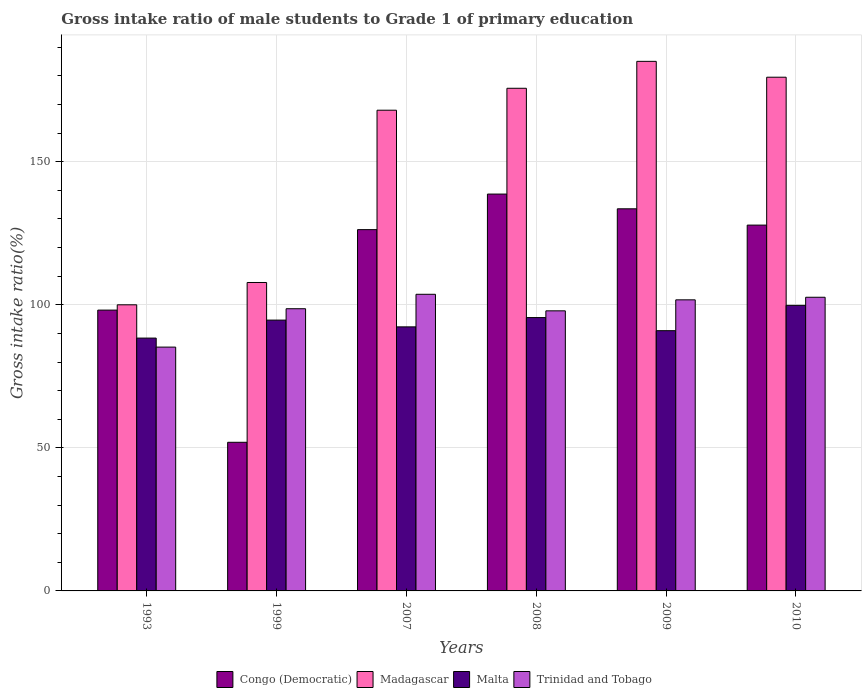How many different coloured bars are there?
Give a very brief answer. 4. How many groups of bars are there?
Offer a terse response. 6. Are the number of bars per tick equal to the number of legend labels?
Make the answer very short. Yes. Are the number of bars on each tick of the X-axis equal?
Offer a very short reply. Yes. How many bars are there on the 2nd tick from the left?
Your answer should be compact. 4. How many bars are there on the 2nd tick from the right?
Your answer should be very brief. 4. What is the label of the 5th group of bars from the left?
Your response must be concise. 2009. In how many cases, is the number of bars for a given year not equal to the number of legend labels?
Keep it short and to the point. 0. What is the gross intake ratio in Madagascar in 1993?
Ensure brevity in your answer.  99.99. Across all years, what is the maximum gross intake ratio in Madagascar?
Your response must be concise. 185.07. Across all years, what is the minimum gross intake ratio in Trinidad and Tobago?
Give a very brief answer. 85.21. In which year was the gross intake ratio in Congo (Democratic) maximum?
Your answer should be very brief. 2008. What is the total gross intake ratio in Malta in the graph?
Your answer should be very brief. 561.55. What is the difference between the gross intake ratio in Congo (Democratic) in 1999 and that in 2010?
Your response must be concise. -75.9. What is the difference between the gross intake ratio in Malta in 2008 and the gross intake ratio in Madagascar in 2009?
Your answer should be very brief. -89.54. What is the average gross intake ratio in Trinidad and Tobago per year?
Keep it short and to the point. 98.29. In the year 1993, what is the difference between the gross intake ratio in Malta and gross intake ratio in Madagascar?
Your answer should be very brief. -11.63. What is the ratio of the gross intake ratio in Trinidad and Tobago in 1999 to that in 2009?
Make the answer very short. 0.97. Is the difference between the gross intake ratio in Malta in 1999 and 2007 greater than the difference between the gross intake ratio in Madagascar in 1999 and 2007?
Offer a very short reply. Yes. What is the difference between the highest and the second highest gross intake ratio in Congo (Democratic)?
Ensure brevity in your answer.  5.15. What is the difference between the highest and the lowest gross intake ratio in Malta?
Your response must be concise. 11.44. In how many years, is the gross intake ratio in Malta greater than the average gross intake ratio in Malta taken over all years?
Offer a terse response. 3. Is the sum of the gross intake ratio in Congo (Democratic) in 1993 and 1999 greater than the maximum gross intake ratio in Trinidad and Tobago across all years?
Provide a succinct answer. Yes. What does the 4th bar from the left in 2010 represents?
Provide a short and direct response. Trinidad and Tobago. What does the 3rd bar from the right in 2008 represents?
Make the answer very short. Madagascar. How many bars are there?
Offer a very short reply. 24. Are all the bars in the graph horizontal?
Your answer should be very brief. No. How many years are there in the graph?
Your response must be concise. 6. What is the difference between two consecutive major ticks on the Y-axis?
Give a very brief answer. 50. Are the values on the major ticks of Y-axis written in scientific E-notation?
Keep it short and to the point. No. Does the graph contain grids?
Make the answer very short. Yes. How many legend labels are there?
Ensure brevity in your answer.  4. How are the legend labels stacked?
Ensure brevity in your answer.  Horizontal. What is the title of the graph?
Provide a short and direct response. Gross intake ratio of male students to Grade 1 of primary education. What is the label or title of the X-axis?
Provide a succinct answer. Years. What is the label or title of the Y-axis?
Ensure brevity in your answer.  Gross intake ratio(%). What is the Gross intake ratio(%) of Congo (Democratic) in 1993?
Give a very brief answer. 98.14. What is the Gross intake ratio(%) of Madagascar in 1993?
Offer a very short reply. 99.99. What is the Gross intake ratio(%) of Malta in 1993?
Your response must be concise. 88.36. What is the Gross intake ratio(%) of Trinidad and Tobago in 1993?
Your response must be concise. 85.21. What is the Gross intake ratio(%) in Congo (Democratic) in 1999?
Offer a very short reply. 51.94. What is the Gross intake ratio(%) of Madagascar in 1999?
Offer a very short reply. 107.79. What is the Gross intake ratio(%) in Malta in 1999?
Make the answer very short. 94.64. What is the Gross intake ratio(%) in Trinidad and Tobago in 1999?
Keep it short and to the point. 98.62. What is the Gross intake ratio(%) in Congo (Democratic) in 2007?
Offer a terse response. 126.26. What is the Gross intake ratio(%) in Madagascar in 2007?
Give a very brief answer. 168. What is the Gross intake ratio(%) in Malta in 2007?
Ensure brevity in your answer.  92.28. What is the Gross intake ratio(%) of Trinidad and Tobago in 2007?
Provide a short and direct response. 103.66. What is the Gross intake ratio(%) of Congo (Democratic) in 2008?
Provide a short and direct response. 138.69. What is the Gross intake ratio(%) in Madagascar in 2008?
Give a very brief answer. 175.66. What is the Gross intake ratio(%) of Malta in 2008?
Offer a very short reply. 95.53. What is the Gross intake ratio(%) of Trinidad and Tobago in 2008?
Your answer should be compact. 97.88. What is the Gross intake ratio(%) of Congo (Democratic) in 2009?
Offer a very short reply. 133.54. What is the Gross intake ratio(%) of Madagascar in 2009?
Offer a terse response. 185.07. What is the Gross intake ratio(%) in Malta in 2009?
Offer a very short reply. 90.94. What is the Gross intake ratio(%) in Trinidad and Tobago in 2009?
Provide a succinct answer. 101.72. What is the Gross intake ratio(%) of Congo (Democratic) in 2010?
Your response must be concise. 127.85. What is the Gross intake ratio(%) of Madagascar in 2010?
Keep it short and to the point. 179.53. What is the Gross intake ratio(%) of Malta in 2010?
Your answer should be very brief. 99.8. What is the Gross intake ratio(%) of Trinidad and Tobago in 2010?
Give a very brief answer. 102.63. Across all years, what is the maximum Gross intake ratio(%) of Congo (Democratic)?
Provide a short and direct response. 138.69. Across all years, what is the maximum Gross intake ratio(%) in Madagascar?
Provide a succinct answer. 185.07. Across all years, what is the maximum Gross intake ratio(%) of Malta?
Give a very brief answer. 99.8. Across all years, what is the maximum Gross intake ratio(%) of Trinidad and Tobago?
Offer a terse response. 103.66. Across all years, what is the minimum Gross intake ratio(%) in Congo (Democratic)?
Your response must be concise. 51.94. Across all years, what is the minimum Gross intake ratio(%) of Madagascar?
Your answer should be compact. 99.99. Across all years, what is the minimum Gross intake ratio(%) in Malta?
Your response must be concise. 88.36. Across all years, what is the minimum Gross intake ratio(%) of Trinidad and Tobago?
Offer a very short reply. 85.21. What is the total Gross intake ratio(%) of Congo (Democratic) in the graph?
Keep it short and to the point. 676.41. What is the total Gross intake ratio(%) in Madagascar in the graph?
Keep it short and to the point. 916.03. What is the total Gross intake ratio(%) of Malta in the graph?
Offer a terse response. 561.55. What is the total Gross intake ratio(%) of Trinidad and Tobago in the graph?
Give a very brief answer. 589.72. What is the difference between the Gross intake ratio(%) in Congo (Democratic) in 1993 and that in 1999?
Your answer should be very brief. 46.19. What is the difference between the Gross intake ratio(%) of Madagascar in 1993 and that in 1999?
Give a very brief answer. -7.8. What is the difference between the Gross intake ratio(%) in Malta in 1993 and that in 1999?
Your answer should be compact. -6.29. What is the difference between the Gross intake ratio(%) of Trinidad and Tobago in 1993 and that in 1999?
Your response must be concise. -13.41. What is the difference between the Gross intake ratio(%) of Congo (Democratic) in 1993 and that in 2007?
Offer a terse response. -28.12. What is the difference between the Gross intake ratio(%) in Madagascar in 1993 and that in 2007?
Your response must be concise. -68.01. What is the difference between the Gross intake ratio(%) in Malta in 1993 and that in 2007?
Provide a short and direct response. -3.92. What is the difference between the Gross intake ratio(%) of Trinidad and Tobago in 1993 and that in 2007?
Offer a terse response. -18.45. What is the difference between the Gross intake ratio(%) in Congo (Democratic) in 1993 and that in 2008?
Offer a very short reply. -40.55. What is the difference between the Gross intake ratio(%) in Madagascar in 1993 and that in 2008?
Offer a terse response. -75.67. What is the difference between the Gross intake ratio(%) of Malta in 1993 and that in 2008?
Your answer should be very brief. -7.17. What is the difference between the Gross intake ratio(%) in Trinidad and Tobago in 1993 and that in 2008?
Provide a short and direct response. -12.67. What is the difference between the Gross intake ratio(%) in Congo (Democratic) in 1993 and that in 2009?
Your answer should be very brief. -35.4. What is the difference between the Gross intake ratio(%) in Madagascar in 1993 and that in 2009?
Give a very brief answer. -85.08. What is the difference between the Gross intake ratio(%) of Malta in 1993 and that in 2009?
Give a very brief answer. -2.59. What is the difference between the Gross intake ratio(%) in Trinidad and Tobago in 1993 and that in 2009?
Your answer should be very brief. -16.51. What is the difference between the Gross intake ratio(%) of Congo (Democratic) in 1993 and that in 2010?
Your answer should be very brief. -29.71. What is the difference between the Gross intake ratio(%) of Madagascar in 1993 and that in 2010?
Your response must be concise. -79.54. What is the difference between the Gross intake ratio(%) of Malta in 1993 and that in 2010?
Provide a short and direct response. -11.44. What is the difference between the Gross intake ratio(%) in Trinidad and Tobago in 1993 and that in 2010?
Offer a terse response. -17.42. What is the difference between the Gross intake ratio(%) of Congo (Democratic) in 1999 and that in 2007?
Ensure brevity in your answer.  -74.32. What is the difference between the Gross intake ratio(%) in Madagascar in 1999 and that in 2007?
Make the answer very short. -60.21. What is the difference between the Gross intake ratio(%) of Malta in 1999 and that in 2007?
Keep it short and to the point. 2.36. What is the difference between the Gross intake ratio(%) in Trinidad and Tobago in 1999 and that in 2007?
Ensure brevity in your answer.  -5.04. What is the difference between the Gross intake ratio(%) in Congo (Democratic) in 1999 and that in 2008?
Keep it short and to the point. -86.75. What is the difference between the Gross intake ratio(%) in Madagascar in 1999 and that in 2008?
Give a very brief answer. -67.87. What is the difference between the Gross intake ratio(%) of Malta in 1999 and that in 2008?
Keep it short and to the point. -0.89. What is the difference between the Gross intake ratio(%) in Trinidad and Tobago in 1999 and that in 2008?
Your response must be concise. 0.74. What is the difference between the Gross intake ratio(%) in Congo (Democratic) in 1999 and that in 2009?
Offer a very short reply. -81.59. What is the difference between the Gross intake ratio(%) of Madagascar in 1999 and that in 2009?
Your answer should be very brief. -77.28. What is the difference between the Gross intake ratio(%) of Malta in 1999 and that in 2009?
Provide a short and direct response. 3.7. What is the difference between the Gross intake ratio(%) in Trinidad and Tobago in 1999 and that in 2009?
Offer a very short reply. -3.1. What is the difference between the Gross intake ratio(%) in Congo (Democratic) in 1999 and that in 2010?
Give a very brief answer. -75.9. What is the difference between the Gross intake ratio(%) in Madagascar in 1999 and that in 2010?
Ensure brevity in your answer.  -71.74. What is the difference between the Gross intake ratio(%) of Malta in 1999 and that in 2010?
Offer a very short reply. -5.16. What is the difference between the Gross intake ratio(%) of Trinidad and Tobago in 1999 and that in 2010?
Make the answer very short. -4.01. What is the difference between the Gross intake ratio(%) of Congo (Democratic) in 2007 and that in 2008?
Your answer should be very brief. -12.43. What is the difference between the Gross intake ratio(%) in Madagascar in 2007 and that in 2008?
Ensure brevity in your answer.  -7.67. What is the difference between the Gross intake ratio(%) of Malta in 2007 and that in 2008?
Offer a very short reply. -3.25. What is the difference between the Gross intake ratio(%) in Trinidad and Tobago in 2007 and that in 2008?
Give a very brief answer. 5.78. What is the difference between the Gross intake ratio(%) in Congo (Democratic) in 2007 and that in 2009?
Make the answer very short. -7.28. What is the difference between the Gross intake ratio(%) in Madagascar in 2007 and that in 2009?
Offer a very short reply. -17.07. What is the difference between the Gross intake ratio(%) in Malta in 2007 and that in 2009?
Your answer should be compact. 1.34. What is the difference between the Gross intake ratio(%) of Trinidad and Tobago in 2007 and that in 2009?
Give a very brief answer. 1.94. What is the difference between the Gross intake ratio(%) of Congo (Democratic) in 2007 and that in 2010?
Give a very brief answer. -1.58. What is the difference between the Gross intake ratio(%) of Madagascar in 2007 and that in 2010?
Your answer should be very brief. -11.53. What is the difference between the Gross intake ratio(%) in Malta in 2007 and that in 2010?
Provide a succinct answer. -7.52. What is the difference between the Gross intake ratio(%) in Trinidad and Tobago in 2007 and that in 2010?
Your answer should be very brief. 1.03. What is the difference between the Gross intake ratio(%) of Congo (Democratic) in 2008 and that in 2009?
Your answer should be very brief. 5.15. What is the difference between the Gross intake ratio(%) in Madagascar in 2008 and that in 2009?
Provide a short and direct response. -9.41. What is the difference between the Gross intake ratio(%) in Malta in 2008 and that in 2009?
Ensure brevity in your answer.  4.58. What is the difference between the Gross intake ratio(%) of Trinidad and Tobago in 2008 and that in 2009?
Your response must be concise. -3.85. What is the difference between the Gross intake ratio(%) in Congo (Democratic) in 2008 and that in 2010?
Keep it short and to the point. 10.84. What is the difference between the Gross intake ratio(%) in Madagascar in 2008 and that in 2010?
Give a very brief answer. -3.87. What is the difference between the Gross intake ratio(%) in Malta in 2008 and that in 2010?
Your answer should be very brief. -4.27. What is the difference between the Gross intake ratio(%) in Trinidad and Tobago in 2008 and that in 2010?
Offer a very short reply. -4.75. What is the difference between the Gross intake ratio(%) in Congo (Democratic) in 2009 and that in 2010?
Your answer should be compact. 5.69. What is the difference between the Gross intake ratio(%) in Madagascar in 2009 and that in 2010?
Provide a succinct answer. 5.54. What is the difference between the Gross intake ratio(%) in Malta in 2009 and that in 2010?
Provide a succinct answer. -8.86. What is the difference between the Gross intake ratio(%) of Trinidad and Tobago in 2009 and that in 2010?
Ensure brevity in your answer.  -0.91. What is the difference between the Gross intake ratio(%) in Congo (Democratic) in 1993 and the Gross intake ratio(%) in Madagascar in 1999?
Offer a terse response. -9.65. What is the difference between the Gross intake ratio(%) of Congo (Democratic) in 1993 and the Gross intake ratio(%) of Malta in 1999?
Ensure brevity in your answer.  3.49. What is the difference between the Gross intake ratio(%) in Congo (Democratic) in 1993 and the Gross intake ratio(%) in Trinidad and Tobago in 1999?
Ensure brevity in your answer.  -0.48. What is the difference between the Gross intake ratio(%) in Madagascar in 1993 and the Gross intake ratio(%) in Malta in 1999?
Make the answer very short. 5.35. What is the difference between the Gross intake ratio(%) of Madagascar in 1993 and the Gross intake ratio(%) of Trinidad and Tobago in 1999?
Ensure brevity in your answer.  1.37. What is the difference between the Gross intake ratio(%) of Malta in 1993 and the Gross intake ratio(%) of Trinidad and Tobago in 1999?
Provide a short and direct response. -10.26. What is the difference between the Gross intake ratio(%) of Congo (Democratic) in 1993 and the Gross intake ratio(%) of Madagascar in 2007?
Your response must be concise. -69.86. What is the difference between the Gross intake ratio(%) in Congo (Democratic) in 1993 and the Gross intake ratio(%) in Malta in 2007?
Make the answer very short. 5.86. What is the difference between the Gross intake ratio(%) in Congo (Democratic) in 1993 and the Gross intake ratio(%) in Trinidad and Tobago in 2007?
Make the answer very short. -5.53. What is the difference between the Gross intake ratio(%) of Madagascar in 1993 and the Gross intake ratio(%) of Malta in 2007?
Your answer should be very brief. 7.71. What is the difference between the Gross intake ratio(%) of Madagascar in 1993 and the Gross intake ratio(%) of Trinidad and Tobago in 2007?
Make the answer very short. -3.67. What is the difference between the Gross intake ratio(%) in Malta in 1993 and the Gross intake ratio(%) in Trinidad and Tobago in 2007?
Offer a very short reply. -15.31. What is the difference between the Gross intake ratio(%) in Congo (Democratic) in 1993 and the Gross intake ratio(%) in Madagascar in 2008?
Give a very brief answer. -77.53. What is the difference between the Gross intake ratio(%) of Congo (Democratic) in 1993 and the Gross intake ratio(%) of Malta in 2008?
Give a very brief answer. 2.61. What is the difference between the Gross intake ratio(%) in Congo (Democratic) in 1993 and the Gross intake ratio(%) in Trinidad and Tobago in 2008?
Provide a short and direct response. 0.26. What is the difference between the Gross intake ratio(%) of Madagascar in 1993 and the Gross intake ratio(%) of Malta in 2008?
Your answer should be very brief. 4.46. What is the difference between the Gross intake ratio(%) in Madagascar in 1993 and the Gross intake ratio(%) in Trinidad and Tobago in 2008?
Provide a succinct answer. 2.11. What is the difference between the Gross intake ratio(%) in Malta in 1993 and the Gross intake ratio(%) in Trinidad and Tobago in 2008?
Give a very brief answer. -9.52. What is the difference between the Gross intake ratio(%) of Congo (Democratic) in 1993 and the Gross intake ratio(%) of Madagascar in 2009?
Offer a terse response. -86.93. What is the difference between the Gross intake ratio(%) of Congo (Democratic) in 1993 and the Gross intake ratio(%) of Malta in 2009?
Your response must be concise. 7.19. What is the difference between the Gross intake ratio(%) in Congo (Democratic) in 1993 and the Gross intake ratio(%) in Trinidad and Tobago in 2009?
Keep it short and to the point. -3.59. What is the difference between the Gross intake ratio(%) of Madagascar in 1993 and the Gross intake ratio(%) of Malta in 2009?
Offer a very short reply. 9.05. What is the difference between the Gross intake ratio(%) in Madagascar in 1993 and the Gross intake ratio(%) in Trinidad and Tobago in 2009?
Keep it short and to the point. -1.73. What is the difference between the Gross intake ratio(%) of Malta in 1993 and the Gross intake ratio(%) of Trinidad and Tobago in 2009?
Offer a terse response. -13.37. What is the difference between the Gross intake ratio(%) of Congo (Democratic) in 1993 and the Gross intake ratio(%) of Madagascar in 2010?
Offer a very short reply. -81.39. What is the difference between the Gross intake ratio(%) of Congo (Democratic) in 1993 and the Gross intake ratio(%) of Malta in 2010?
Your response must be concise. -1.66. What is the difference between the Gross intake ratio(%) in Congo (Democratic) in 1993 and the Gross intake ratio(%) in Trinidad and Tobago in 2010?
Your answer should be compact. -4.49. What is the difference between the Gross intake ratio(%) of Madagascar in 1993 and the Gross intake ratio(%) of Malta in 2010?
Make the answer very short. 0.19. What is the difference between the Gross intake ratio(%) of Madagascar in 1993 and the Gross intake ratio(%) of Trinidad and Tobago in 2010?
Provide a succinct answer. -2.64. What is the difference between the Gross intake ratio(%) of Malta in 1993 and the Gross intake ratio(%) of Trinidad and Tobago in 2010?
Provide a short and direct response. -14.27. What is the difference between the Gross intake ratio(%) in Congo (Democratic) in 1999 and the Gross intake ratio(%) in Madagascar in 2007?
Keep it short and to the point. -116.05. What is the difference between the Gross intake ratio(%) in Congo (Democratic) in 1999 and the Gross intake ratio(%) in Malta in 2007?
Ensure brevity in your answer.  -40.34. What is the difference between the Gross intake ratio(%) of Congo (Democratic) in 1999 and the Gross intake ratio(%) of Trinidad and Tobago in 2007?
Your answer should be compact. -51.72. What is the difference between the Gross intake ratio(%) in Madagascar in 1999 and the Gross intake ratio(%) in Malta in 2007?
Make the answer very short. 15.51. What is the difference between the Gross intake ratio(%) of Madagascar in 1999 and the Gross intake ratio(%) of Trinidad and Tobago in 2007?
Provide a succinct answer. 4.13. What is the difference between the Gross intake ratio(%) in Malta in 1999 and the Gross intake ratio(%) in Trinidad and Tobago in 2007?
Offer a very short reply. -9.02. What is the difference between the Gross intake ratio(%) in Congo (Democratic) in 1999 and the Gross intake ratio(%) in Madagascar in 2008?
Your answer should be very brief. -123.72. What is the difference between the Gross intake ratio(%) of Congo (Democratic) in 1999 and the Gross intake ratio(%) of Malta in 2008?
Your answer should be compact. -43.58. What is the difference between the Gross intake ratio(%) of Congo (Democratic) in 1999 and the Gross intake ratio(%) of Trinidad and Tobago in 2008?
Keep it short and to the point. -45.93. What is the difference between the Gross intake ratio(%) in Madagascar in 1999 and the Gross intake ratio(%) in Malta in 2008?
Your response must be concise. 12.26. What is the difference between the Gross intake ratio(%) of Madagascar in 1999 and the Gross intake ratio(%) of Trinidad and Tobago in 2008?
Keep it short and to the point. 9.91. What is the difference between the Gross intake ratio(%) in Malta in 1999 and the Gross intake ratio(%) in Trinidad and Tobago in 2008?
Offer a terse response. -3.24. What is the difference between the Gross intake ratio(%) in Congo (Democratic) in 1999 and the Gross intake ratio(%) in Madagascar in 2009?
Ensure brevity in your answer.  -133.12. What is the difference between the Gross intake ratio(%) of Congo (Democratic) in 1999 and the Gross intake ratio(%) of Malta in 2009?
Provide a short and direct response. -39. What is the difference between the Gross intake ratio(%) of Congo (Democratic) in 1999 and the Gross intake ratio(%) of Trinidad and Tobago in 2009?
Keep it short and to the point. -49.78. What is the difference between the Gross intake ratio(%) of Madagascar in 1999 and the Gross intake ratio(%) of Malta in 2009?
Offer a very short reply. 16.84. What is the difference between the Gross intake ratio(%) in Madagascar in 1999 and the Gross intake ratio(%) in Trinidad and Tobago in 2009?
Give a very brief answer. 6.06. What is the difference between the Gross intake ratio(%) in Malta in 1999 and the Gross intake ratio(%) in Trinidad and Tobago in 2009?
Ensure brevity in your answer.  -7.08. What is the difference between the Gross intake ratio(%) of Congo (Democratic) in 1999 and the Gross intake ratio(%) of Madagascar in 2010?
Provide a short and direct response. -127.58. What is the difference between the Gross intake ratio(%) of Congo (Democratic) in 1999 and the Gross intake ratio(%) of Malta in 2010?
Offer a terse response. -47.86. What is the difference between the Gross intake ratio(%) of Congo (Democratic) in 1999 and the Gross intake ratio(%) of Trinidad and Tobago in 2010?
Provide a succinct answer. -50.68. What is the difference between the Gross intake ratio(%) in Madagascar in 1999 and the Gross intake ratio(%) in Malta in 2010?
Provide a succinct answer. 7.99. What is the difference between the Gross intake ratio(%) of Madagascar in 1999 and the Gross intake ratio(%) of Trinidad and Tobago in 2010?
Your response must be concise. 5.16. What is the difference between the Gross intake ratio(%) of Malta in 1999 and the Gross intake ratio(%) of Trinidad and Tobago in 2010?
Provide a succinct answer. -7.99. What is the difference between the Gross intake ratio(%) of Congo (Democratic) in 2007 and the Gross intake ratio(%) of Madagascar in 2008?
Ensure brevity in your answer.  -49.4. What is the difference between the Gross intake ratio(%) of Congo (Democratic) in 2007 and the Gross intake ratio(%) of Malta in 2008?
Give a very brief answer. 30.73. What is the difference between the Gross intake ratio(%) of Congo (Democratic) in 2007 and the Gross intake ratio(%) of Trinidad and Tobago in 2008?
Your answer should be very brief. 28.38. What is the difference between the Gross intake ratio(%) of Madagascar in 2007 and the Gross intake ratio(%) of Malta in 2008?
Your answer should be compact. 72.47. What is the difference between the Gross intake ratio(%) of Madagascar in 2007 and the Gross intake ratio(%) of Trinidad and Tobago in 2008?
Offer a very short reply. 70.12. What is the difference between the Gross intake ratio(%) in Malta in 2007 and the Gross intake ratio(%) in Trinidad and Tobago in 2008?
Give a very brief answer. -5.6. What is the difference between the Gross intake ratio(%) of Congo (Democratic) in 2007 and the Gross intake ratio(%) of Madagascar in 2009?
Ensure brevity in your answer.  -58.81. What is the difference between the Gross intake ratio(%) of Congo (Democratic) in 2007 and the Gross intake ratio(%) of Malta in 2009?
Ensure brevity in your answer.  35.32. What is the difference between the Gross intake ratio(%) in Congo (Democratic) in 2007 and the Gross intake ratio(%) in Trinidad and Tobago in 2009?
Offer a terse response. 24.54. What is the difference between the Gross intake ratio(%) of Madagascar in 2007 and the Gross intake ratio(%) of Malta in 2009?
Give a very brief answer. 77.05. What is the difference between the Gross intake ratio(%) of Madagascar in 2007 and the Gross intake ratio(%) of Trinidad and Tobago in 2009?
Your answer should be compact. 66.27. What is the difference between the Gross intake ratio(%) in Malta in 2007 and the Gross intake ratio(%) in Trinidad and Tobago in 2009?
Keep it short and to the point. -9.44. What is the difference between the Gross intake ratio(%) in Congo (Democratic) in 2007 and the Gross intake ratio(%) in Madagascar in 2010?
Give a very brief answer. -53.27. What is the difference between the Gross intake ratio(%) of Congo (Democratic) in 2007 and the Gross intake ratio(%) of Malta in 2010?
Offer a terse response. 26.46. What is the difference between the Gross intake ratio(%) in Congo (Democratic) in 2007 and the Gross intake ratio(%) in Trinidad and Tobago in 2010?
Your answer should be very brief. 23.63. What is the difference between the Gross intake ratio(%) in Madagascar in 2007 and the Gross intake ratio(%) in Malta in 2010?
Your answer should be very brief. 68.2. What is the difference between the Gross intake ratio(%) of Madagascar in 2007 and the Gross intake ratio(%) of Trinidad and Tobago in 2010?
Offer a very short reply. 65.37. What is the difference between the Gross intake ratio(%) in Malta in 2007 and the Gross intake ratio(%) in Trinidad and Tobago in 2010?
Your response must be concise. -10.35. What is the difference between the Gross intake ratio(%) of Congo (Democratic) in 2008 and the Gross intake ratio(%) of Madagascar in 2009?
Your answer should be compact. -46.38. What is the difference between the Gross intake ratio(%) of Congo (Democratic) in 2008 and the Gross intake ratio(%) of Malta in 2009?
Provide a succinct answer. 47.75. What is the difference between the Gross intake ratio(%) of Congo (Democratic) in 2008 and the Gross intake ratio(%) of Trinidad and Tobago in 2009?
Your response must be concise. 36.97. What is the difference between the Gross intake ratio(%) of Madagascar in 2008 and the Gross intake ratio(%) of Malta in 2009?
Keep it short and to the point. 84.72. What is the difference between the Gross intake ratio(%) in Madagascar in 2008 and the Gross intake ratio(%) in Trinidad and Tobago in 2009?
Keep it short and to the point. 73.94. What is the difference between the Gross intake ratio(%) in Malta in 2008 and the Gross intake ratio(%) in Trinidad and Tobago in 2009?
Your response must be concise. -6.2. What is the difference between the Gross intake ratio(%) of Congo (Democratic) in 2008 and the Gross intake ratio(%) of Madagascar in 2010?
Your answer should be very brief. -40.84. What is the difference between the Gross intake ratio(%) in Congo (Democratic) in 2008 and the Gross intake ratio(%) in Malta in 2010?
Make the answer very short. 38.89. What is the difference between the Gross intake ratio(%) of Congo (Democratic) in 2008 and the Gross intake ratio(%) of Trinidad and Tobago in 2010?
Ensure brevity in your answer.  36.06. What is the difference between the Gross intake ratio(%) in Madagascar in 2008 and the Gross intake ratio(%) in Malta in 2010?
Offer a very short reply. 75.86. What is the difference between the Gross intake ratio(%) of Madagascar in 2008 and the Gross intake ratio(%) of Trinidad and Tobago in 2010?
Offer a terse response. 73.03. What is the difference between the Gross intake ratio(%) of Malta in 2008 and the Gross intake ratio(%) of Trinidad and Tobago in 2010?
Offer a very short reply. -7.1. What is the difference between the Gross intake ratio(%) in Congo (Democratic) in 2009 and the Gross intake ratio(%) in Madagascar in 2010?
Your answer should be compact. -45.99. What is the difference between the Gross intake ratio(%) of Congo (Democratic) in 2009 and the Gross intake ratio(%) of Malta in 2010?
Ensure brevity in your answer.  33.74. What is the difference between the Gross intake ratio(%) in Congo (Democratic) in 2009 and the Gross intake ratio(%) in Trinidad and Tobago in 2010?
Your response must be concise. 30.91. What is the difference between the Gross intake ratio(%) of Madagascar in 2009 and the Gross intake ratio(%) of Malta in 2010?
Offer a terse response. 85.27. What is the difference between the Gross intake ratio(%) in Madagascar in 2009 and the Gross intake ratio(%) in Trinidad and Tobago in 2010?
Give a very brief answer. 82.44. What is the difference between the Gross intake ratio(%) in Malta in 2009 and the Gross intake ratio(%) in Trinidad and Tobago in 2010?
Offer a very short reply. -11.68. What is the average Gross intake ratio(%) in Congo (Democratic) per year?
Keep it short and to the point. 112.74. What is the average Gross intake ratio(%) of Madagascar per year?
Offer a very short reply. 152.67. What is the average Gross intake ratio(%) in Malta per year?
Provide a short and direct response. 93.59. What is the average Gross intake ratio(%) in Trinidad and Tobago per year?
Offer a very short reply. 98.29. In the year 1993, what is the difference between the Gross intake ratio(%) of Congo (Democratic) and Gross intake ratio(%) of Madagascar?
Offer a terse response. -1.85. In the year 1993, what is the difference between the Gross intake ratio(%) in Congo (Democratic) and Gross intake ratio(%) in Malta?
Give a very brief answer. 9.78. In the year 1993, what is the difference between the Gross intake ratio(%) of Congo (Democratic) and Gross intake ratio(%) of Trinidad and Tobago?
Ensure brevity in your answer.  12.93. In the year 1993, what is the difference between the Gross intake ratio(%) of Madagascar and Gross intake ratio(%) of Malta?
Make the answer very short. 11.63. In the year 1993, what is the difference between the Gross intake ratio(%) of Madagascar and Gross intake ratio(%) of Trinidad and Tobago?
Ensure brevity in your answer.  14.78. In the year 1993, what is the difference between the Gross intake ratio(%) of Malta and Gross intake ratio(%) of Trinidad and Tobago?
Provide a short and direct response. 3.15. In the year 1999, what is the difference between the Gross intake ratio(%) of Congo (Democratic) and Gross intake ratio(%) of Madagascar?
Keep it short and to the point. -55.84. In the year 1999, what is the difference between the Gross intake ratio(%) in Congo (Democratic) and Gross intake ratio(%) in Malta?
Ensure brevity in your answer.  -42.7. In the year 1999, what is the difference between the Gross intake ratio(%) of Congo (Democratic) and Gross intake ratio(%) of Trinidad and Tobago?
Make the answer very short. -46.67. In the year 1999, what is the difference between the Gross intake ratio(%) of Madagascar and Gross intake ratio(%) of Malta?
Your response must be concise. 13.15. In the year 1999, what is the difference between the Gross intake ratio(%) in Madagascar and Gross intake ratio(%) in Trinidad and Tobago?
Give a very brief answer. 9.17. In the year 1999, what is the difference between the Gross intake ratio(%) of Malta and Gross intake ratio(%) of Trinidad and Tobago?
Ensure brevity in your answer.  -3.98. In the year 2007, what is the difference between the Gross intake ratio(%) of Congo (Democratic) and Gross intake ratio(%) of Madagascar?
Offer a very short reply. -41.74. In the year 2007, what is the difference between the Gross intake ratio(%) in Congo (Democratic) and Gross intake ratio(%) in Malta?
Give a very brief answer. 33.98. In the year 2007, what is the difference between the Gross intake ratio(%) of Congo (Democratic) and Gross intake ratio(%) of Trinidad and Tobago?
Your response must be concise. 22.6. In the year 2007, what is the difference between the Gross intake ratio(%) of Madagascar and Gross intake ratio(%) of Malta?
Offer a very short reply. 75.72. In the year 2007, what is the difference between the Gross intake ratio(%) of Madagascar and Gross intake ratio(%) of Trinidad and Tobago?
Give a very brief answer. 64.33. In the year 2007, what is the difference between the Gross intake ratio(%) in Malta and Gross intake ratio(%) in Trinidad and Tobago?
Provide a succinct answer. -11.38. In the year 2008, what is the difference between the Gross intake ratio(%) of Congo (Democratic) and Gross intake ratio(%) of Madagascar?
Make the answer very short. -36.97. In the year 2008, what is the difference between the Gross intake ratio(%) of Congo (Democratic) and Gross intake ratio(%) of Malta?
Keep it short and to the point. 43.16. In the year 2008, what is the difference between the Gross intake ratio(%) of Congo (Democratic) and Gross intake ratio(%) of Trinidad and Tobago?
Your response must be concise. 40.81. In the year 2008, what is the difference between the Gross intake ratio(%) of Madagascar and Gross intake ratio(%) of Malta?
Provide a short and direct response. 80.13. In the year 2008, what is the difference between the Gross intake ratio(%) in Madagascar and Gross intake ratio(%) in Trinidad and Tobago?
Provide a short and direct response. 77.78. In the year 2008, what is the difference between the Gross intake ratio(%) of Malta and Gross intake ratio(%) of Trinidad and Tobago?
Offer a very short reply. -2.35. In the year 2009, what is the difference between the Gross intake ratio(%) in Congo (Democratic) and Gross intake ratio(%) in Madagascar?
Give a very brief answer. -51.53. In the year 2009, what is the difference between the Gross intake ratio(%) of Congo (Democratic) and Gross intake ratio(%) of Malta?
Your response must be concise. 42.59. In the year 2009, what is the difference between the Gross intake ratio(%) in Congo (Democratic) and Gross intake ratio(%) in Trinidad and Tobago?
Your answer should be very brief. 31.81. In the year 2009, what is the difference between the Gross intake ratio(%) in Madagascar and Gross intake ratio(%) in Malta?
Provide a short and direct response. 94.12. In the year 2009, what is the difference between the Gross intake ratio(%) in Madagascar and Gross intake ratio(%) in Trinidad and Tobago?
Your answer should be compact. 83.34. In the year 2009, what is the difference between the Gross intake ratio(%) in Malta and Gross intake ratio(%) in Trinidad and Tobago?
Provide a short and direct response. -10.78. In the year 2010, what is the difference between the Gross intake ratio(%) in Congo (Democratic) and Gross intake ratio(%) in Madagascar?
Keep it short and to the point. -51.68. In the year 2010, what is the difference between the Gross intake ratio(%) of Congo (Democratic) and Gross intake ratio(%) of Malta?
Provide a short and direct response. 28.05. In the year 2010, what is the difference between the Gross intake ratio(%) of Congo (Democratic) and Gross intake ratio(%) of Trinidad and Tobago?
Make the answer very short. 25.22. In the year 2010, what is the difference between the Gross intake ratio(%) of Madagascar and Gross intake ratio(%) of Malta?
Offer a very short reply. 79.73. In the year 2010, what is the difference between the Gross intake ratio(%) in Madagascar and Gross intake ratio(%) in Trinidad and Tobago?
Make the answer very short. 76.9. In the year 2010, what is the difference between the Gross intake ratio(%) in Malta and Gross intake ratio(%) in Trinidad and Tobago?
Ensure brevity in your answer.  -2.83. What is the ratio of the Gross intake ratio(%) of Congo (Democratic) in 1993 to that in 1999?
Make the answer very short. 1.89. What is the ratio of the Gross intake ratio(%) in Madagascar in 1993 to that in 1999?
Provide a short and direct response. 0.93. What is the ratio of the Gross intake ratio(%) in Malta in 1993 to that in 1999?
Make the answer very short. 0.93. What is the ratio of the Gross intake ratio(%) in Trinidad and Tobago in 1993 to that in 1999?
Your answer should be very brief. 0.86. What is the ratio of the Gross intake ratio(%) of Congo (Democratic) in 1993 to that in 2007?
Make the answer very short. 0.78. What is the ratio of the Gross intake ratio(%) in Madagascar in 1993 to that in 2007?
Keep it short and to the point. 0.6. What is the ratio of the Gross intake ratio(%) of Malta in 1993 to that in 2007?
Your answer should be compact. 0.96. What is the ratio of the Gross intake ratio(%) in Trinidad and Tobago in 1993 to that in 2007?
Offer a terse response. 0.82. What is the ratio of the Gross intake ratio(%) in Congo (Democratic) in 1993 to that in 2008?
Give a very brief answer. 0.71. What is the ratio of the Gross intake ratio(%) of Madagascar in 1993 to that in 2008?
Offer a very short reply. 0.57. What is the ratio of the Gross intake ratio(%) of Malta in 1993 to that in 2008?
Provide a short and direct response. 0.92. What is the ratio of the Gross intake ratio(%) in Trinidad and Tobago in 1993 to that in 2008?
Your answer should be very brief. 0.87. What is the ratio of the Gross intake ratio(%) in Congo (Democratic) in 1993 to that in 2009?
Give a very brief answer. 0.73. What is the ratio of the Gross intake ratio(%) in Madagascar in 1993 to that in 2009?
Provide a short and direct response. 0.54. What is the ratio of the Gross intake ratio(%) in Malta in 1993 to that in 2009?
Your response must be concise. 0.97. What is the ratio of the Gross intake ratio(%) in Trinidad and Tobago in 1993 to that in 2009?
Keep it short and to the point. 0.84. What is the ratio of the Gross intake ratio(%) of Congo (Democratic) in 1993 to that in 2010?
Make the answer very short. 0.77. What is the ratio of the Gross intake ratio(%) of Madagascar in 1993 to that in 2010?
Offer a terse response. 0.56. What is the ratio of the Gross intake ratio(%) of Malta in 1993 to that in 2010?
Provide a succinct answer. 0.89. What is the ratio of the Gross intake ratio(%) in Trinidad and Tobago in 1993 to that in 2010?
Ensure brevity in your answer.  0.83. What is the ratio of the Gross intake ratio(%) of Congo (Democratic) in 1999 to that in 2007?
Make the answer very short. 0.41. What is the ratio of the Gross intake ratio(%) of Madagascar in 1999 to that in 2007?
Your answer should be compact. 0.64. What is the ratio of the Gross intake ratio(%) in Malta in 1999 to that in 2007?
Your answer should be compact. 1.03. What is the ratio of the Gross intake ratio(%) in Trinidad and Tobago in 1999 to that in 2007?
Make the answer very short. 0.95. What is the ratio of the Gross intake ratio(%) in Congo (Democratic) in 1999 to that in 2008?
Ensure brevity in your answer.  0.37. What is the ratio of the Gross intake ratio(%) in Madagascar in 1999 to that in 2008?
Offer a terse response. 0.61. What is the ratio of the Gross intake ratio(%) in Trinidad and Tobago in 1999 to that in 2008?
Offer a terse response. 1.01. What is the ratio of the Gross intake ratio(%) in Congo (Democratic) in 1999 to that in 2009?
Your response must be concise. 0.39. What is the ratio of the Gross intake ratio(%) of Madagascar in 1999 to that in 2009?
Give a very brief answer. 0.58. What is the ratio of the Gross intake ratio(%) of Malta in 1999 to that in 2009?
Your answer should be compact. 1.04. What is the ratio of the Gross intake ratio(%) of Trinidad and Tobago in 1999 to that in 2009?
Give a very brief answer. 0.97. What is the ratio of the Gross intake ratio(%) in Congo (Democratic) in 1999 to that in 2010?
Provide a succinct answer. 0.41. What is the ratio of the Gross intake ratio(%) in Madagascar in 1999 to that in 2010?
Your answer should be very brief. 0.6. What is the ratio of the Gross intake ratio(%) in Malta in 1999 to that in 2010?
Your response must be concise. 0.95. What is the ratio of the Gross intake ratio(%) of Trinidad and Tobago in 1999 to that in 2010?
Ensure brevity in your answer.  0.96. What is the ratio of the Gross intake ratio(%) in Congo (Democratic) in 2007 to that in 2008?
Provide a short and direct response. 0.91. What is the ratio of the Gross intake ratio(%) of Madagascar in 2007 to that in 2008?
Provide a short and direct response. 0.96. What is the ratio of the Gross intake ratio(%) of Trinidad and Tobago in 2007 to that in 2008?
Provide a succinct answer. 1.06. What is the ratio of the Gross intake ratio(%) of Congo (Democratic) in 2007 to that in 2009?
Give a very brief answer. 0.95. What is the ratio of the Gross intake ratio(%) of Madagascar in 2007 to that in 2009?
Offer a very short reply. 0.91. What is the ratio of the Gross intake ratio(%) of Malta in 2007 to that in 2009?
Your response must be concise. 1.01. What is the ratio of the Gross intake ratio(%) in Trinidad and Tobago in 2007 to that in 2009?
Provide a short and direct response. 1.02. What is the ratio of the Gross intake ratio(%) of Congo (Democratic) in 2007 to that in 2010?
Give a very brief answer. 0.99. What is the ratio of the Gross intake ratio(%) in Madagascar in 2007 to that in 2010?
Make the answer very short. 0.94. What is the ratio of the Gross intake ratio(%) in Malta in 2007 to that in 2010?
Your answer should be compact. 0.92. What is the ratio of the Gross intake ratio(%) of Trinidad and Tobago in 2007 to that in 2010?
Your answer should be compact. 1.01. What is the ratio of the Gross intake ratio(%) in Congo (Democratic) in 2008 to that in 2009?
Keep it short and to the point. 1.04. What is the ratio of the Gross intake ratio(%) in Madagascar in 2008 to that in 2009?
Give a very brief answer. 0.95. What is the ratio of the Gross intake ratio(%) of Malta in 2008 to that in 2009?
Your response must be concise. 1.05. What is the ratio of the Gross intake ratio(%) of Trinidad and Tobago in 2008 to that in 2009?
Provide a succinct answer. 0.96. What is the ratio of the Gross intake ratio(%) in Congo (Democratic) in 2008 to that in 2010?
Your answer should be compact. 1.08. What is the ratio of the Gross intake ratio(%) of Madagascar in 2008 to that in 2010?
Your answer should be very brief. 0.98. What is the ratio of the Gross intake ratio(%) of Malta in 2008 to that in 2010?
Offer a very short reply. 0.96. What is the ratio of the Gross intake ratio(%) of Trinidad and Tobago in 2008 to that in 2010?
Ensure brevity in your answer.  0.95. What is the ratio of the Gross intake ratio(%) in Congo (Democratic) in 2009 to that in 2010?
Offer a very short reply. 1.04. What is the ratio of the Gross intake ratio(%) in Madagascar in 2009 to that in 2010?
Make the answer very short. 1.03. What is the ratio of the Gross intake ratio(%) in Malta in 2009 to that in 2010?
Keep it short and to the point. 0.91. What is the ratio of the Gross intake ratio(%) of Trinidad and Tobago in 2009 to that in 2010?
Offer a terse response. 0.99. What is the difference between the highest and the second highest Gross intake ratio(%) in Congo (Democratic)?
Provide a succinct answer. 5.15. What is the difference between the highest and the second highest Gross intake ratio(%) of Madagascar?
Offer a very short reply. 5.54. What is the difference between the highest and the second highest Gross intake ratio(%) of Malta?
Offer a very short reply. 4.27. What is the difference between the highest and the second highest Gross intake ratio(%) of Trinidad and Tobago?
Your answer should be very brief. 1.03. What is the difference between the highest and the lowest Gross intake ratio(%) of Congo (Democratic)?
Your answer should be compact. 86.75. What is the difference between the highest and the lowest Gross intake ratio(%) of Madagascar?
Provide a short and direct response. 85.08. What is the difference between the highest and the lowest Gross intake ratio(%) in Malta?
Give a very brief answer. 11.44. What is the difference between the highest and the lowest Gross intake ratio(%) in Trinidad and Tobago?
Give a very brief answer. 18.45. 